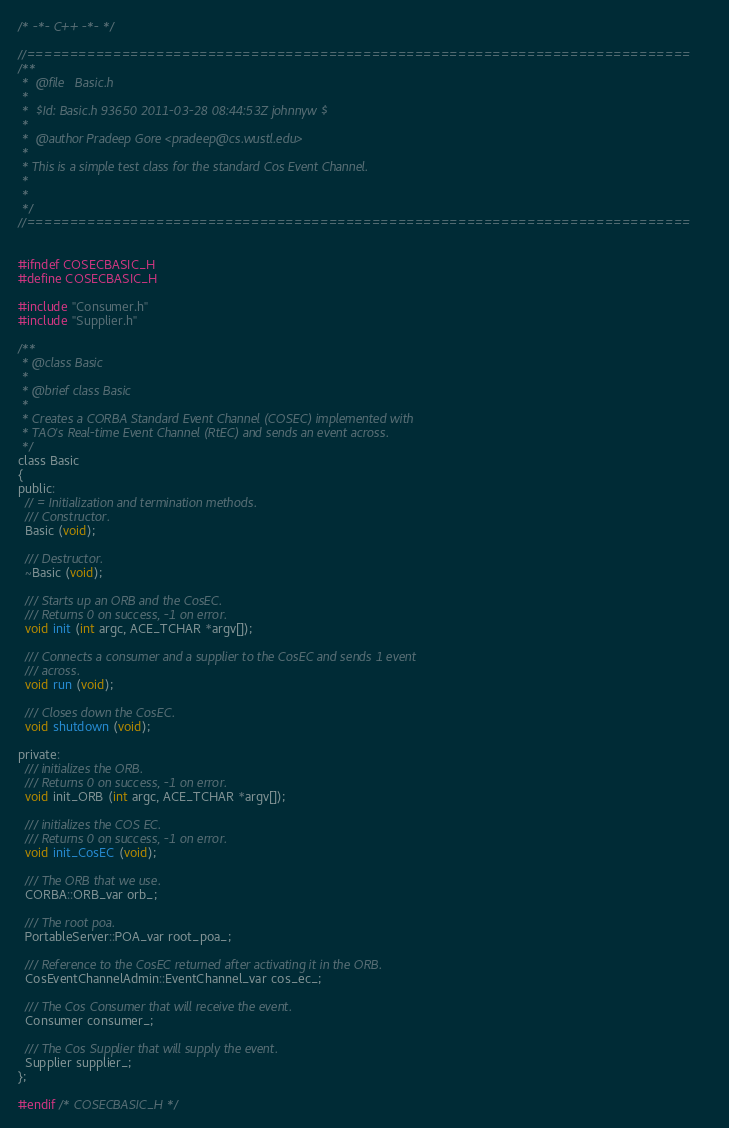Convert code to text. <code><loc_0><loc_0><loc_500><loc_500><_C_>/* -*- C++ -*- */

//=============================================================================
/**
 *  @file   Basic.h
 *
 *  $Id: Basic.h 93650 2011-03-28 08:44:53Z johnnyw $
 *
 *  @author Pradeep Gore <pradeep@cs.wustl.edu>
 *
 * This is a simple test class for the standard Cos Event Channel.
 *
 *
 */
//=============================================================================


#ifndef COSECBASIC_H
#define COSECBASIC_H

#include "Consumer.h"
#include "Supplier.h"

/**
 * @class Basic
 *
 * @brief class Basic
 *
 * Creates a CORBA Standard Event Channel (COSEC) implemented with
 * TAO's Real-time Event Channel (RtEC) and sends an event across.
 */
class Basic
{
public:
  // = Initialization and termination methods.
  /// Constructor.
  Basic (void);

  /// Destructor.
  ~Basic (void);

  /// Starts up an ORB and the CosEC.
  /// Returns 0 on success, -1 on error.
  void init (int argc, ACE_TCHAR *argv[]);

  /// Connects a consumer and a supplier to the CosEC and sends 1 event
  /// across.
  void run (void);

  /// Closes down the CosEC.
  void shutdown (void);

private:
  /// initializes the ORB.
  /// Returns 0 on success, -1 on error.
  void init_ORB (int argc, ACE_TCHAR *argv[]);

  /// initializes the COS EC.
  /// Returns 0 on success, -1 on error.
  void init_CosEC (void);

  /// The ORB that we use.
  CORBA::ORB_var orb_;

  /// The root poa.
  PortableServer::POA_var root_poa_;

  /// Reference to the CosEC returned after activating it in the ORB.
  CosEventChannelAdmin::EventChannel_var cos_ec_;

  /// The Cos Consumer that will receive the event.
  Consumer consumer_;

  /// The Cos Supplier that will supply the event.
  Supplier supplier_;
};

#endif /* COSECBASIC_H */
</code> 